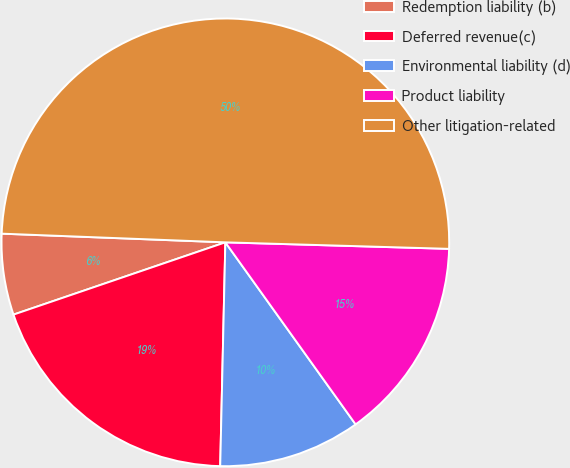Convert chart to OTSL. <chart><loc_0><loc_0><loc_500><loc_500><pie_chart><fcel>Redemption liability (b)<fcel>Deferred revenue(c)<fcel>Environmental liability (d)<fcel>Product liability<fcel>Other litigation-related<nl><fcel>5.85%<fcel>19.4%<fcel>10.25%<fcel>14.65%<fcel>49.84%<nl></chart> 